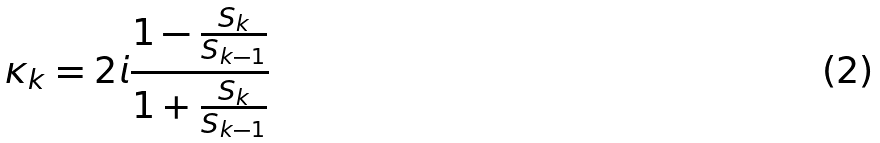Convert formula to latex. <formula><loc_0><loc_0><loc_500><loc_500>\kappa _ { k } = 2 i \frac { 1 - \frac { S _ { k } } { S _ { k - 1 } } } { 1 + \frac { S _ { k } } { S _ { k - 1 } } }</formula> 